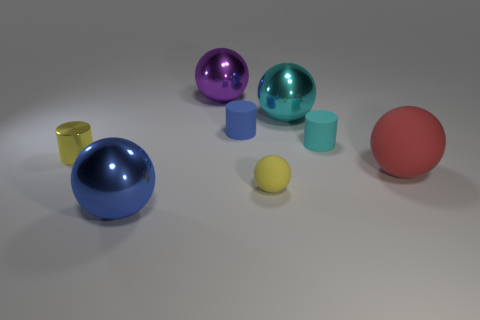What number of purple metal objects are the same shape as the big blue shiny object?
Offer a very short reply. 1. Is there another gray ball that has the same material as the small sphere?
Make the answer very short. No. What material is the blue object that is behind the small object left of the purple thing made of?
Provide a short and direct response. Rubber. There is a shiny ball in front of the small yellow metallic object; how big is it?
Provide a succinct answer. Large. There is a small metallic cylinder; does it have the same color as the large metal ball in front of the small metal object?
Ensure brevity in your answer.  No. Are there any shiny balls that have the same color as the metallic cylinder?
Make the answer very short. No. Does the big purple ball have the same material as the small cylinder on the right side of the cyan shiny object?
Your answer should be very brief. No. How many large objects are red spheres or metallic objects?
Offer a very short reply. 4. What material is the other small thing that is the same color as the small metal thing?
Provide a short and direct response. Rubber. Is the number of large rubber things less than the number of shiny things?
Your answer should be very brief. Yes. 